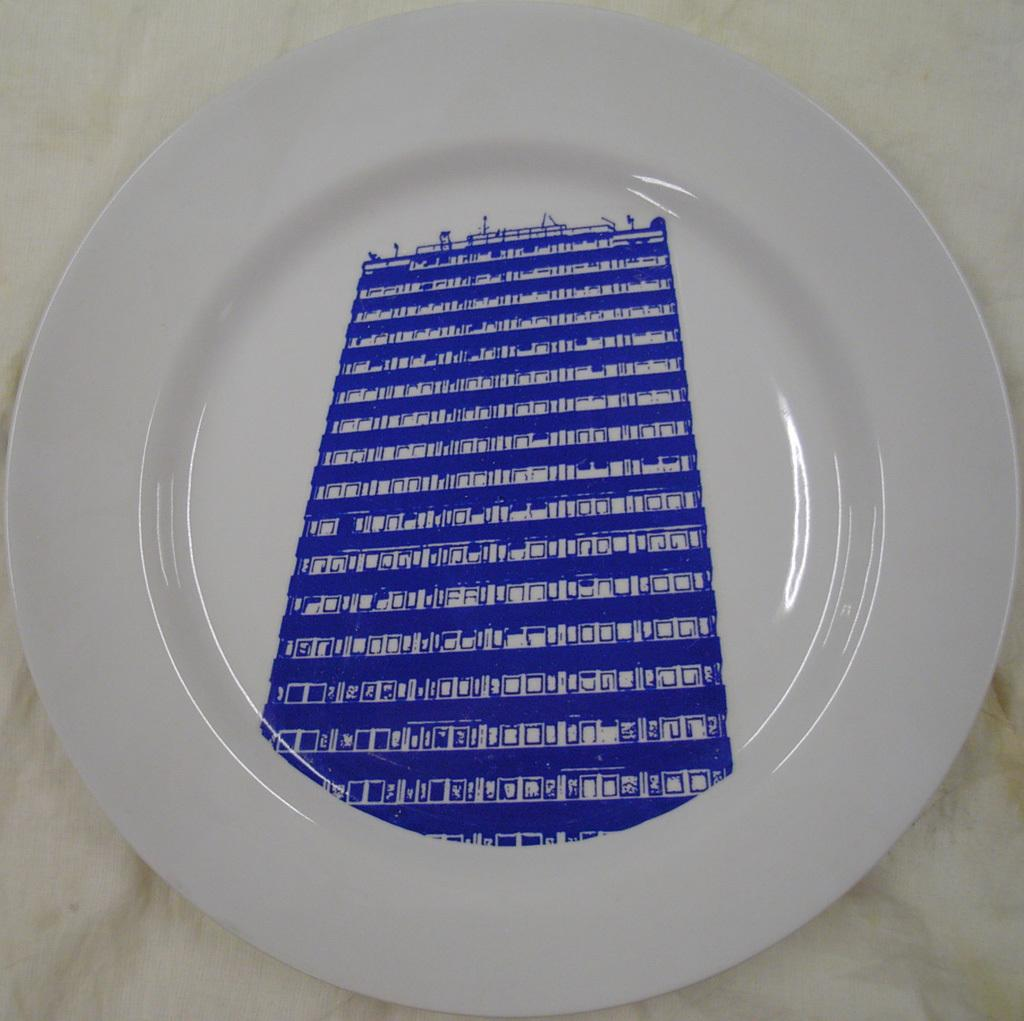What object is present in the image that is typically used for holding food? There is a plate in the image. What is depicted on the plate? There is an image of a building on the plate. What type of guitar is the creator playing in the image? There is no guitar or creator present in the image. What tool is being used to hammer the nails into the building on the plate? There is no hammer or nails present in the image; it only features an image of a building on the plate. 